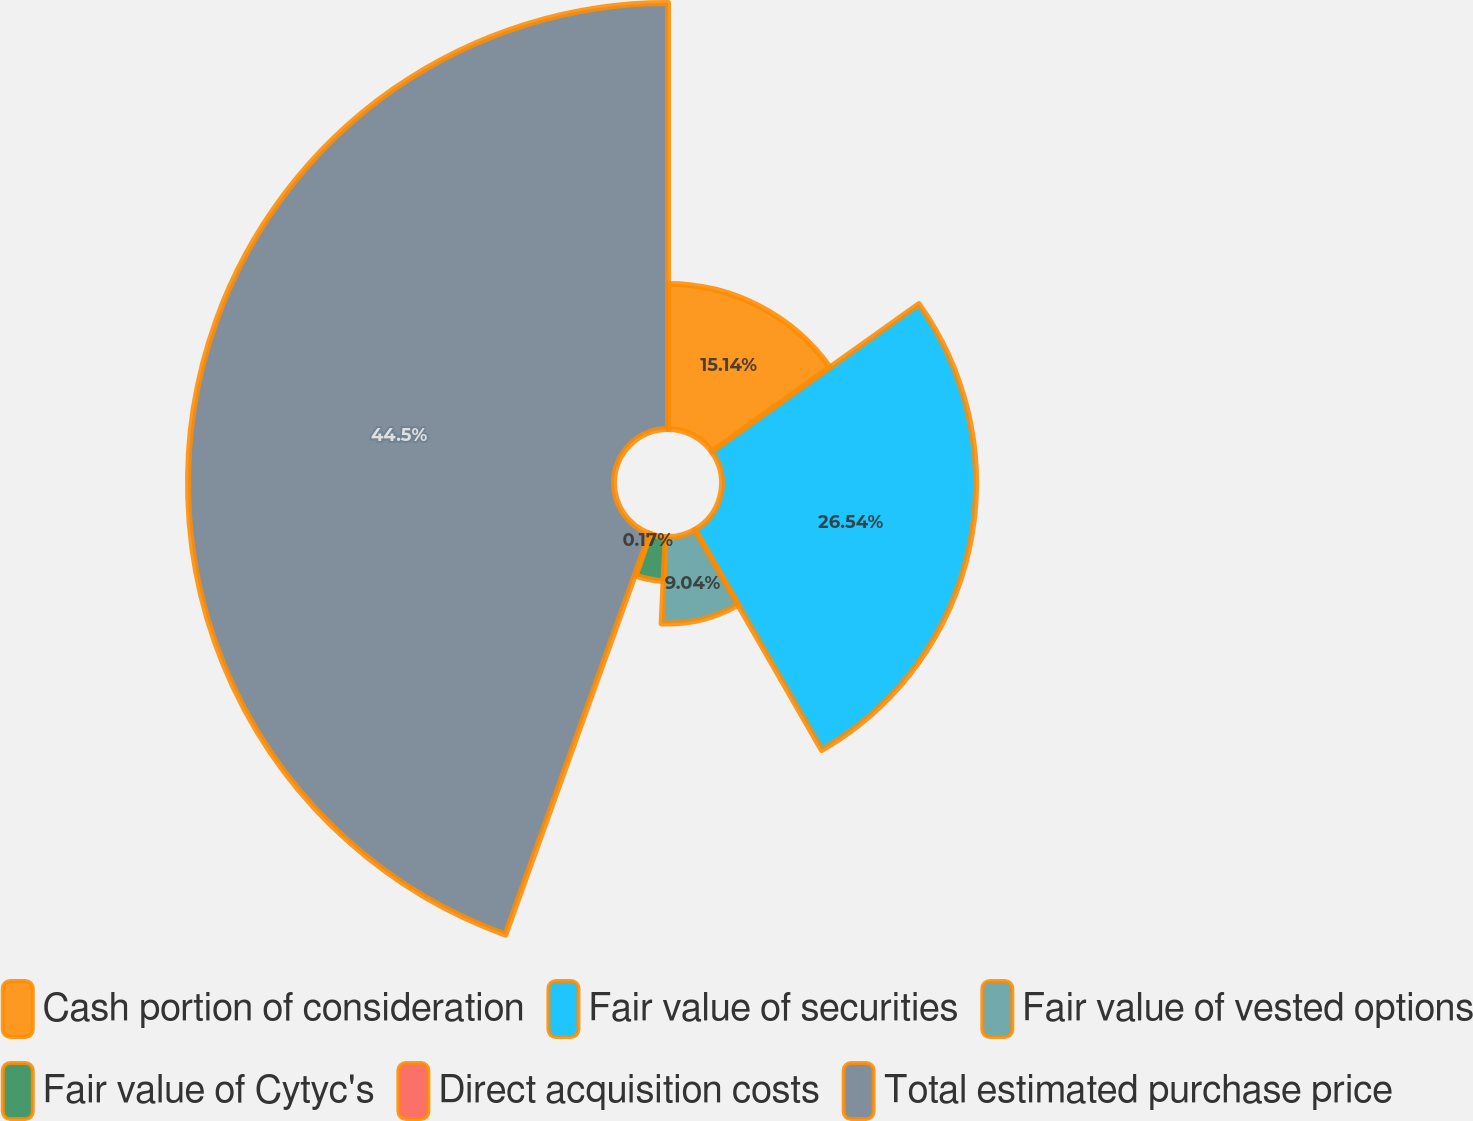<chart> <loc_0><loc_0><loc_500><loc_500><pie_chart><fcel>Cash portion of consideration<fcel>Fair value of securities<fcel>Fair value of vested options<fcel>Fair value of Cytyc's<fcel>Direct acquisition costs<fcel>Total estimated purchase price<nl><fcel>15.14%<fcel>26.54%<fcel>9.04%<fcel>4.61%<fcel>0.17%<fcel>44.5%<nl></chart> 